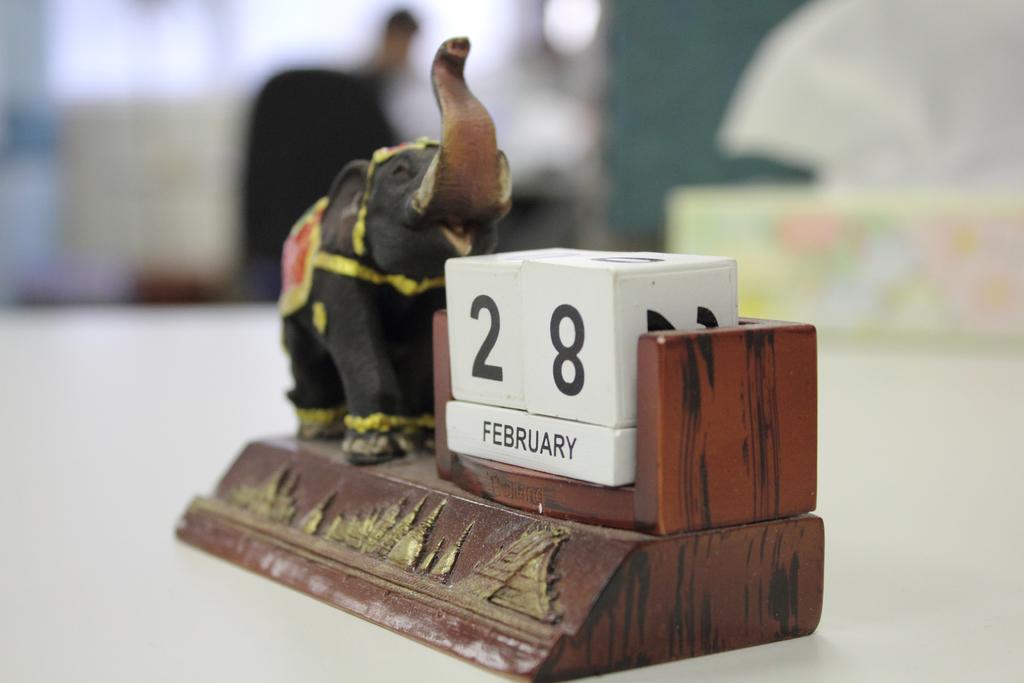What is the date displayed?
Offer a terse response. February 28. What month is displayed?
Keep it short and to the point. February. 